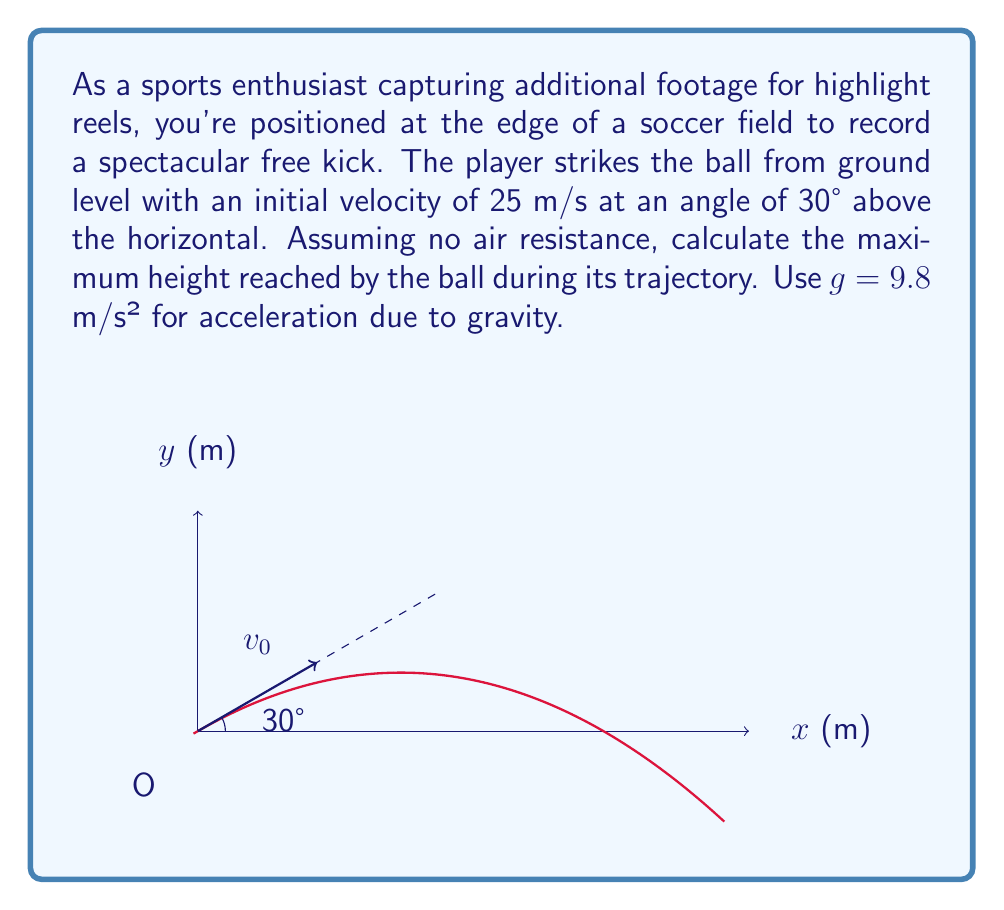Teach me how to tackle this problem. To solve this problem, we'll use the equations of motion for projectile motion. Let's break it down step-by-step:

1) The maximum height is reached when the vertical velocity becomes zero. We need to find the time it takes to reach this point and then calculate the height.

2) Given:
   - Initial velocity, $v_0 = 25$ m/s
   - Angle of projection, $\theta = 30°$
   - Acceleration due to gravity, $g = 9.8$ m/s²

3) The initial vertical velocity component is:
   $v_{0y} = v_0 \sin \theta = 25 \sin 30° = 25 \cdot 0.5 = 12.5$ m/s

4) Time to reach maximum height:
   At the highest point, $v_y = 0$
   Using the equation $v_y = v_{0y} - gt$, we get:
   $0 = 12.5 - 9.8t$
   $t = \frac{12.5}{9.8} = 1.276$ seconds

5) Now, we can calculate the maximum height using the equation:
   $y = v_{0y}t - \frac{1}{2}gt^2$

   $y = 12.5 \cdot 1.276 - \frac{1}{2} \cdot 9.8 \cdot 1.276^2$
   $y = 15.95 - 7.975 = 7.975$ m

Therefore, the maximum height reached by the ball is approximately 7.975 meters.
Answer: $7.975$ m 